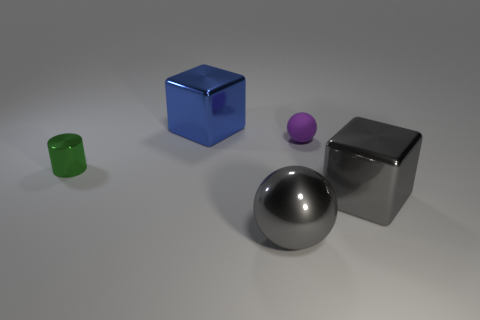Add 4 yellow metallic balls. How many objects exist? 9 Subtract all cylinders. How many objects are left? 4 Add 4 small purple balls. How many small purple balls are left? 5 Add 2 large yellow rubber objects. How many large yellow rubber objects exist? 2 Subtract 0 red cubes. How many objects are left? 5 Subtract all big blue metallic cubes. Subtract all small green metallic cylinders. How many objects are left? 3 